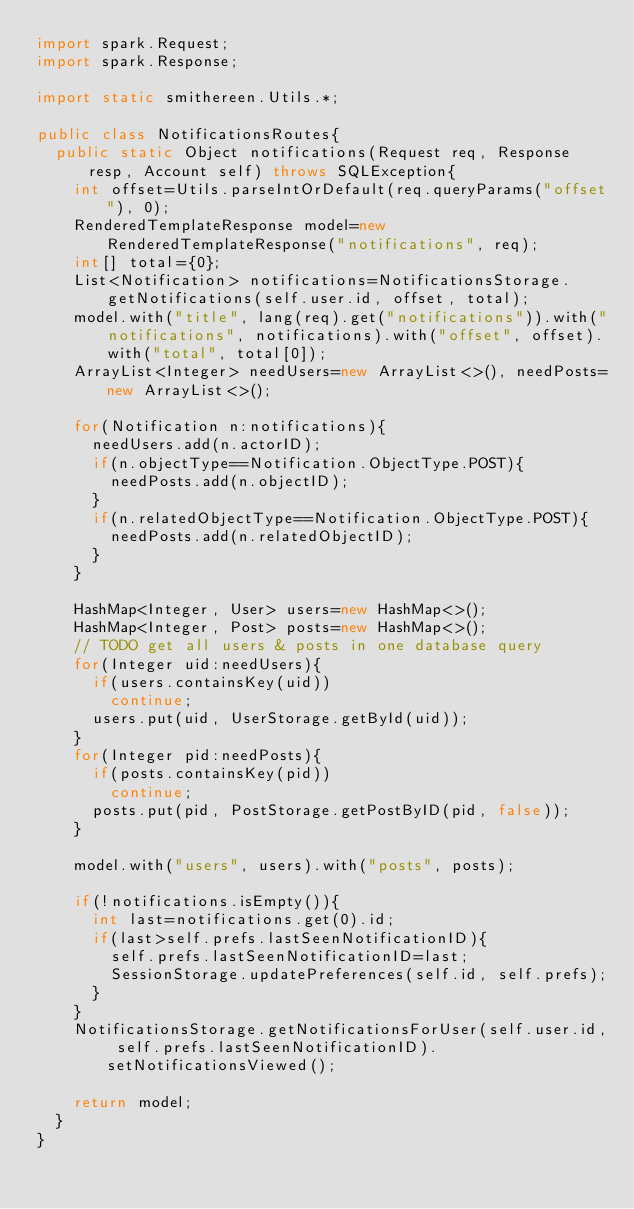<code> <loc_0><loc_0><loc_500><loc_500><_Java_>import spark.Request;
import spark.Response;

import static smithereen.Utils.*;

public class NotificationsRoutes{
	public static Object notifications(Request req, Response resp, Account self) throws SQLException{
		int offset=Utils.parseIntOrDefault(req.queryParams("offset"), 0);
		RenderedTemplateResponse model=new RenderedTemplateResponse("notifications", req);
		int[] total={0};
		List<Notification> notifications=NotificationsStorage.getNotifications(self.user.id, offset, total);
		model.with("title", lang(req).get("notifications")).with("notifications", notifications).with("offset", offset).with("total", total[0]);
		ArrayList<Integer> needUsers=new ArrayList<>(), needPosts=new ArrayList<>();

		for(Notification n:notifications){
			needUsers.add(n.actorID);
			if(n.objectType==Notification.ObjectType.POST){
				needPosts.add(n.objectID);
			}
			if(n.relatedObjectType==Notification.ObjectType.POST){
				needPosts.add(n.relatedObjectID);
			}
		}

		HashMap<Integer, User> users=new HashMap<>();
		HashMap<Integer, Post> posts=new HashMap<>();
		// TODO get all users & posts in one database query
		for(Integer uid:needUsers){
			if(users.containsKey(uid))
				continue;
			users.put(uid, UserStorage.getById(uid));
		}
		for(Integer pid:needPosts){
			if(posts.containsKey(pid))
				continue;
			posts.put(pid, PostStorage.getPostByID(pid, false));
		}

		model.with("users", users).with("posts", posts);

		if(!notifications.isEmpty()){
			int last=notifications.get(0).id;
			if(last>self.prefs.lastSeenNotificationID){
				self.prefs.lastSeenNotificationID=last;
				SessionStorage.updatePreferences(self.id, self.prefs);
			}
		}
		NotificationsStorage.getNotificationsForUser(self.user.id, self.prefs.lastSeenNotificationID).setNotificationsViewed();

		return model;
	}
}
</code> 